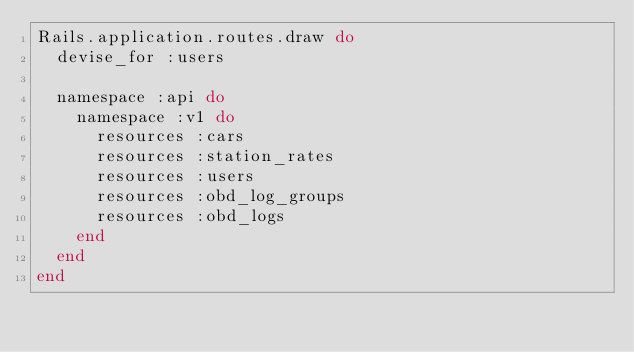<code> <loc_0><loc_0><loc_500><loc_500><_Ruby_>Rails.application.routes.draw do
  devise_for :users

  namespace :api do
    namespace :v1 do
      resources :cars
      resources :station_rates
      resources :users
      resources :obd_log_groups
      resources :obd_logs
    end
  end
end
</code> 